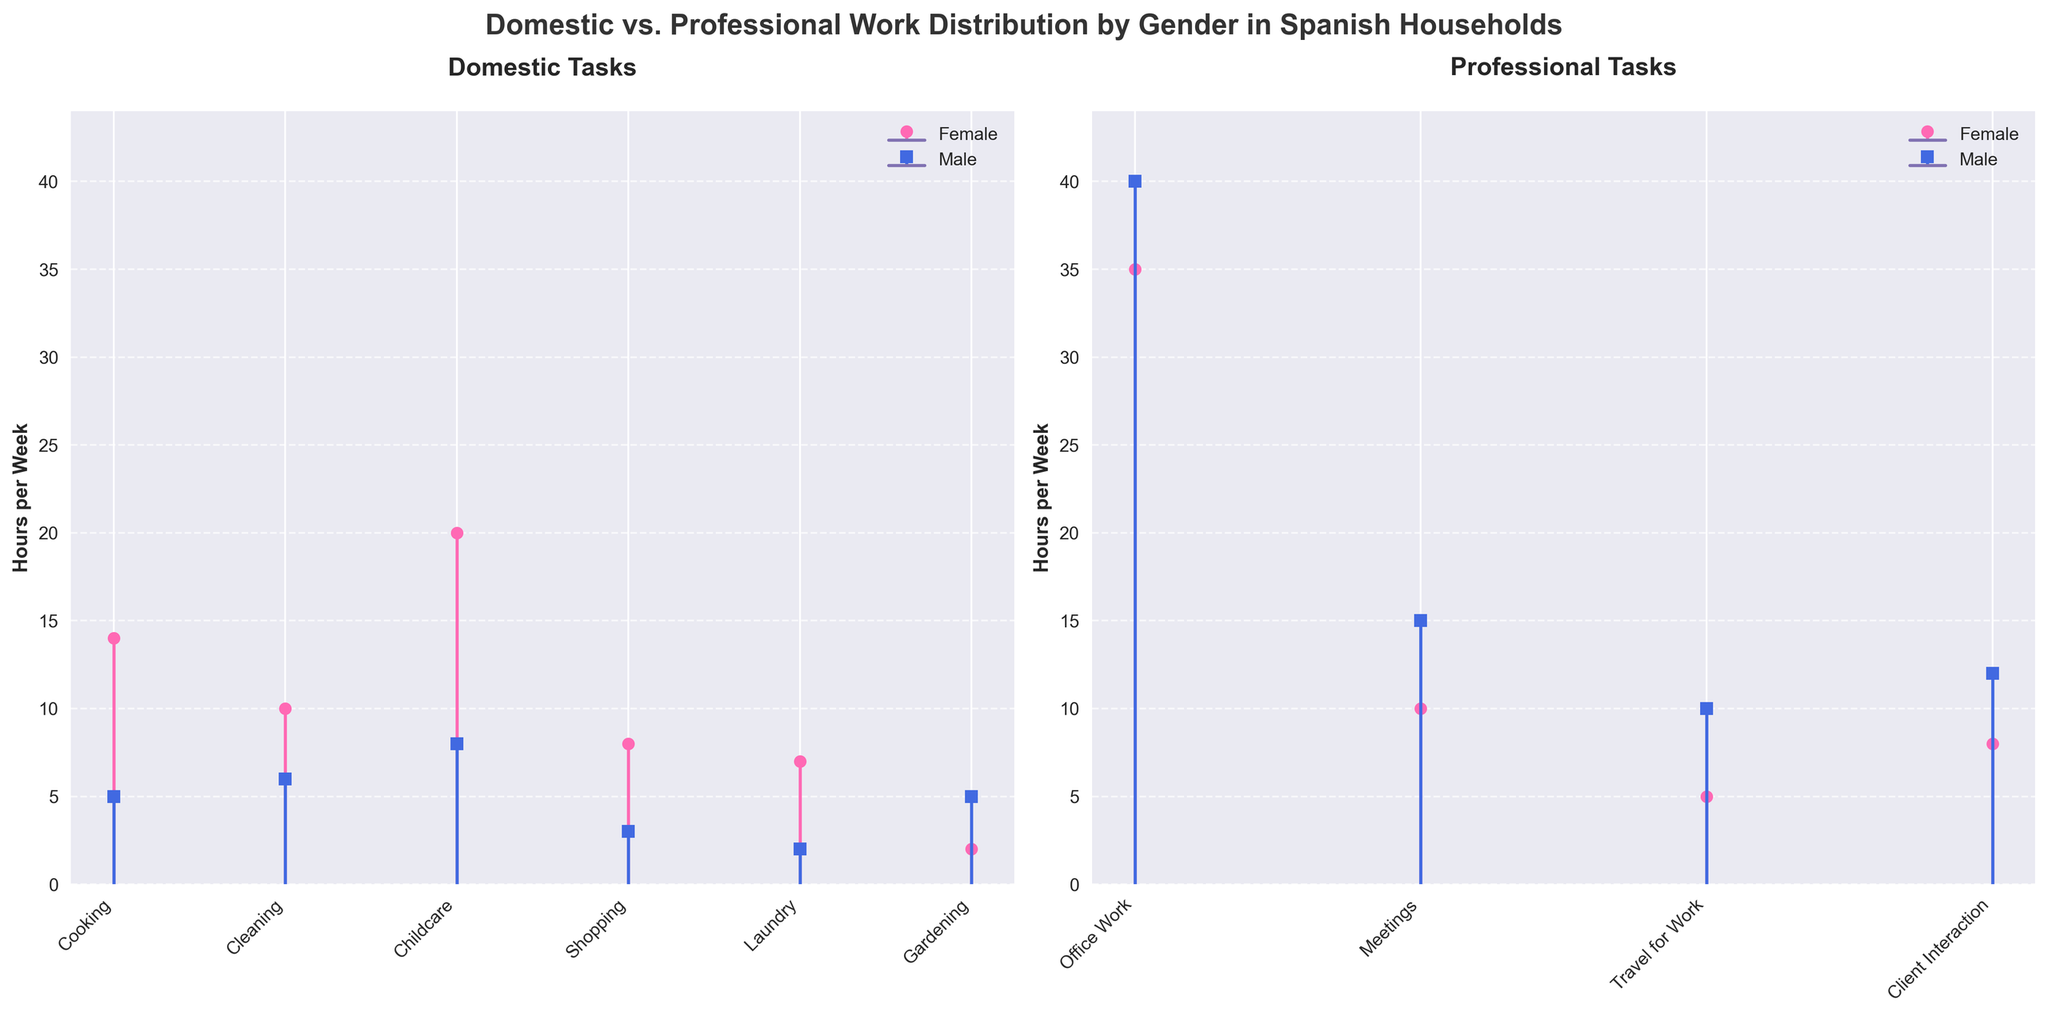What is the title of the figure? The title of the figure is typically positioned at the top and provides a summary of what the figure represents.
Answer: Domestic vs. Professional Work Distribution by Gender in Spanish Households How many tasks are listed under Professional Tasks? To determine the number of professional tasks, we count the individual task labels listed on the x-axis under the "Professional Tasks" subplot.
Answer: 5 Which gender spends more time on childcare? By looking at the heights of the stems for the task "Childcare" in the Domestic subplot, we compare the heights for Female and Male.
Answer: Female How many more hours per week does the female spend on cooking compared to the male? The Female spends 14 hours per week and the Male spends 5 hours per week on cooking. The difference is calculated by subtracting the Male's hours from the Female's hours.
Answer: 9 What is the total number of hours spent by males on Domestic tasks? Sum up the hours per week spent by males on each Domestic task: 5 (Cooking) + 6 (Cleaning) + 8 (Childcare) + 3 (Shopping) + 2 (Laundry) + 5 (Gardening) = 29
Answer: 29 Which professional task has the largest gender gap in hours worked per week? For each Professional task, subtract the Male's hours from the Female's hours and find the task with the maximum absolute difference. Travel for Work has the largest difference of 5 hours (10 - 5).
Answer: Travel for Work What is the average number of hours per week spent by females on Domestic tasks? Sum the hours per week spent by females on Domestic tasks and then divide by the number of Domestic tasks: (14 + 10 + 20 + 8 + 7 + 2) / 6 = 61 / 6 = 10.17
Answer: 10.17 Do males or females spend more time in total on Professional tasks? Sum up the hours per week spent on Professional tasks for each gender and compare: Females (35 + 10 + 5 + 8 = 58) and Males (40 + 15 + 10 + 12 = 77). Males spend more time.
Answer: Males For which task is there the smallest difference in hours spent between genders? Calculate the absolute difference in hours per week for each task and identify the task with the smallest difference. Cooking has a difference of 9 - 5 = 4 hours.
Answer: Cooking 